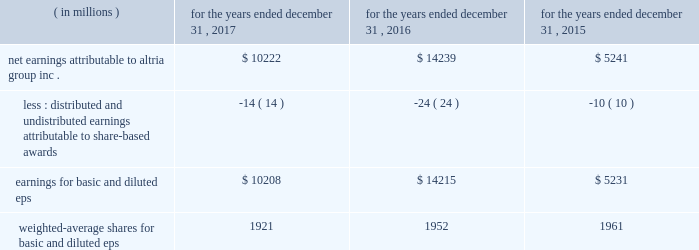10-k altria ar release tuesday , february 27 , 2018 10:00pm andra design llc performance stock units : in january 2017 , altria group , inc .
Granted an aggregate of 187886 performance stock units to eligible employees .
The payout of the performance stock units requires the achievement of certain performance measures , which were predetermined at the time of grant , over a three-year performance cycle .
These performance measures consist of altria group , inc . 2019s adjusted diluted earnings per share ( 201ceps 201d ) compounded annual growth rate and altria group , inc . 2019s total shareholder return relative to a predetermined peer group .
The performance stock units are also subject to forfeiture if certain employment conditions are not met .
At december 31 , 2017 , altria group , inc .
Had 170755 performance stock units remaining , with a weighted-average grant date fair value of $ 70.39 per performance stock unit .
The fair value of the performance stock units at the date of grant , net of estimated forfeitures , is amortized to expense over the performance period .
Altria group , inc .
Recorded pre-tax compensation expense related to performance stock units for the year ended december 31 , 2017 of $ 6 million .
The unamortized compensation expense related to altria group , inc . 2019s performance stock units was $ 7 million at december 31 , 2017 .
Altria group , inc .
Did not grant any performance stock units during 2016 and 2015 .
Note 12 .
Earnings per share basic and diluted eps were calculated using the following: .
Net earnings attributable to altria group , inc .
$ 10222 $ 14239 $ 5241 less : distributed and undistributed earnings attributable to share-based awards ( 14 ) ( 24 ) ( 10 ) earnings for basic and diluted eps $ 10208 $ 14215 $ 5231 weighted-average shares for basic and diluted eps 1921 1952 1961 .
What is the percent change in earnings for basic and diluted eps from 2016 to 2017? 
Computations: ((14215 - 10208) / 10208)
Answer: 0.39254. 